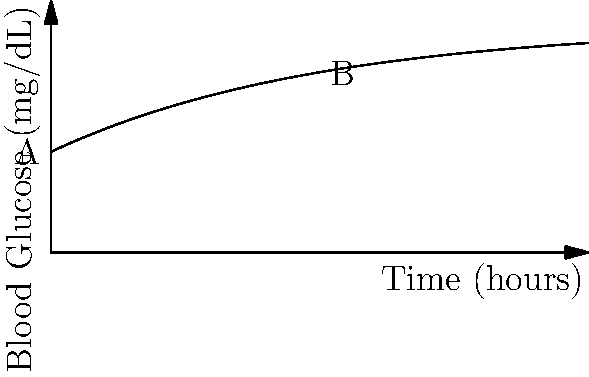The graph shows your blood glucose level over time after taking insulin. If point A represents your initial glucose level and point B represents your glucose level after 2 hours, what is the average rate of change of your blood glucose level during this time period? To find the average rate of change, we need to:

1. Determine the function for blood glucose level:
   $f(x) = 180 - 100e^{-0.5x}$, where $x$ is time in hours

2. Calculate glucose levels at points A and B:
   Point A (0 hours): $f(0) = 180 - 100e^{-0.5(0)} = 180 - 100 = 80$ mg/dL
   Point B (2 hours): $f(2) = 180 - 100e^{-0.5(2)} = 180 - 100e^{-1} \approx 143.25$ mg/dL

3. Calculate the change in glucose level:
   $\Delta y = f(2) - f(0) \approx 143.25 - 80 = 63.25$ mg/dL

4. Calculate the change in time:
   $\Delta x = 2 - 0 = 2$ hours

5. Calculate the average rate of change:
   Average rate of change = $\frac{\Delta y}{\Delta x} = \frac{63.25}{2} \approx 31.625$ mg/dL/hour
Answer: $31.625$ mg/dL/hour 